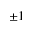Convert formula to latex. <formula><loc_0><loc_0><loc_500><loc_500>\pm 1</formula> 